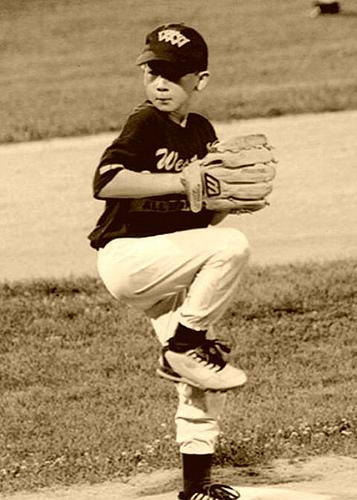Is the photo old?
Concise answer only. Yes. What position is the boy playing?
Give a very brief answer. Pitcher. Is the boy going to throw the mitt?
Write a very short answer. No. 